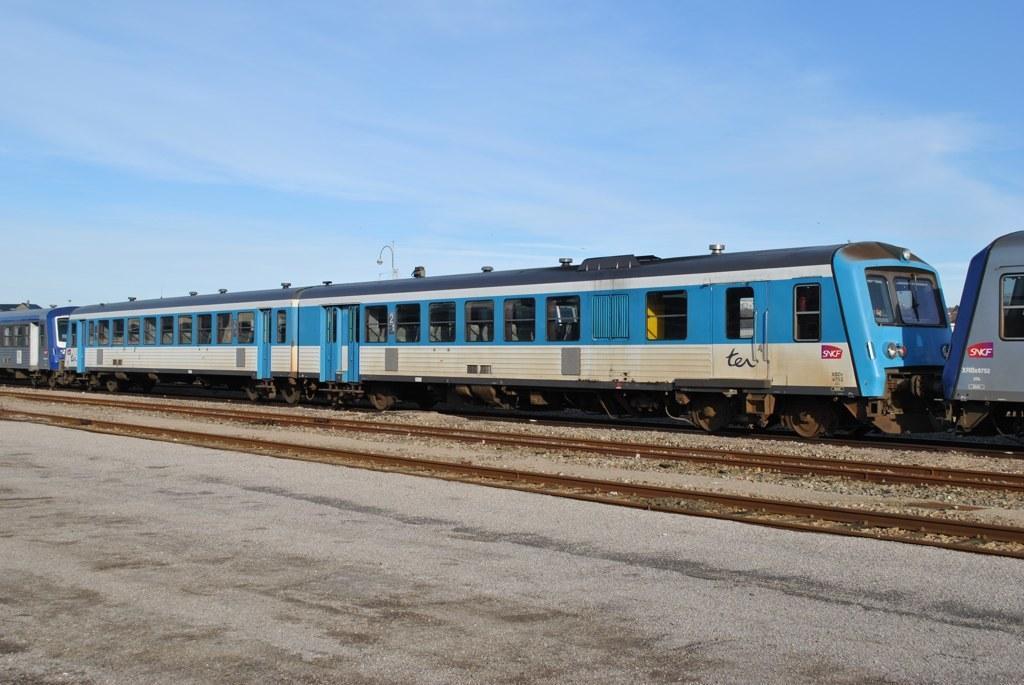Describe this image in one or two sentences. In this image, we can see a train. There are tracks in the middle of the image. There is a cement floor at the bottom of the image. At the top of the image, we can see the sky. 